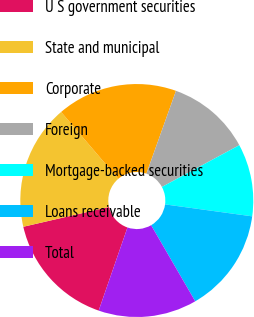Convert chart to OTSL. <chart><loc_0><loc_0><loc_500><loc_500><pie_chart><fcel>U S government securities<fcel>State and municipal<fcel>Corporate<fcel>Foreign<fcel>Mortgage-backed securities<fcel>Loans receivable<fcel>Total<nl><fcel>16.08%<fcel>17.36%<fcel>16.72%<fcel>11.66%<fcel>10.05%<fcel>14.47%<fcel>13.67%<nl></chart> 